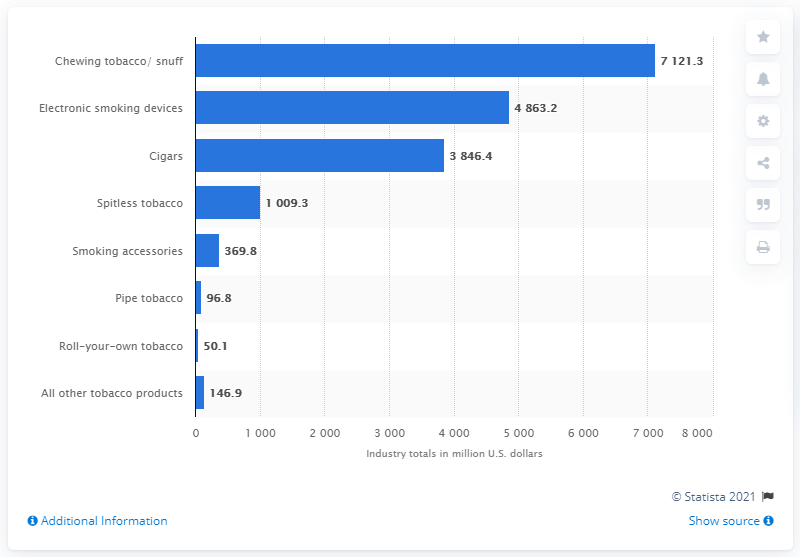List a handful of essential elements in this visual. Cigar sales in the United States in 2020 were approximately $38,464. 